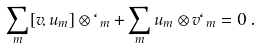Convert formula to latex. <formula><loc_0><loc_0><loc_500><loc_500>\sum _ { m } [ v , u _ { m } ] \otimes \ell _ { m } + \sum _ { m } u _ { m } \otimes v \ell _ { m } = 0 \, .</formula> 